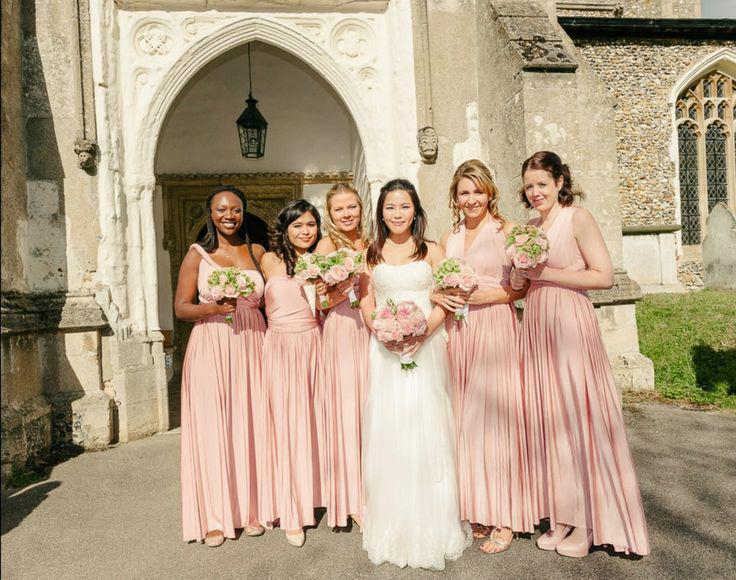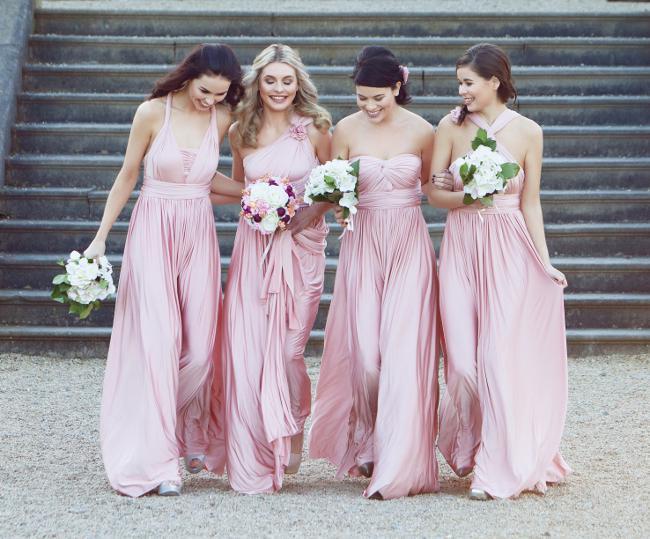The first image is the image on the left, the second image is the image on the right. Analyze the images presented: Is the assertion "There are three women in the left image" valid? Answer yes or no. No. The first image is the image on the left, the second image is the image on the right. For the images displayed, is the sentence "In one image, exactly four women are shown standing in a row." factually correct? Answer yes or no. Yes. 